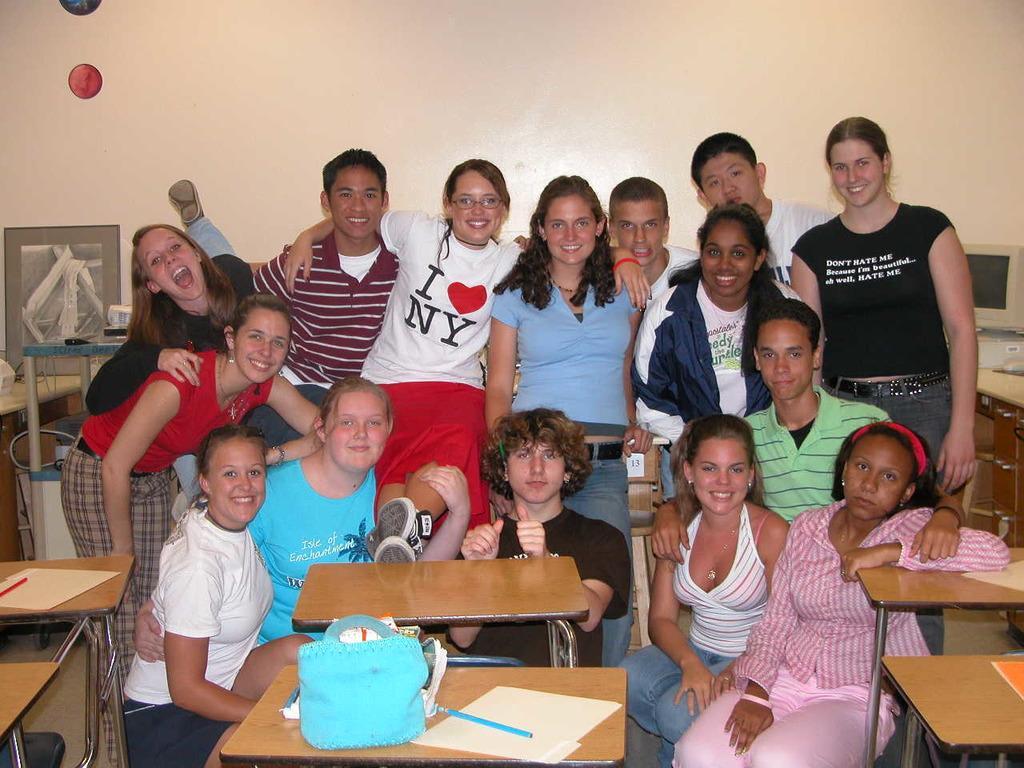Can you describe this image briefly? In this picture we can see a group of people some are sitting on knees on floor and some are standing and some are bending all of them are laughing and in background we can see wall, monitor on table, frame, bags, pen, papers on bench. 